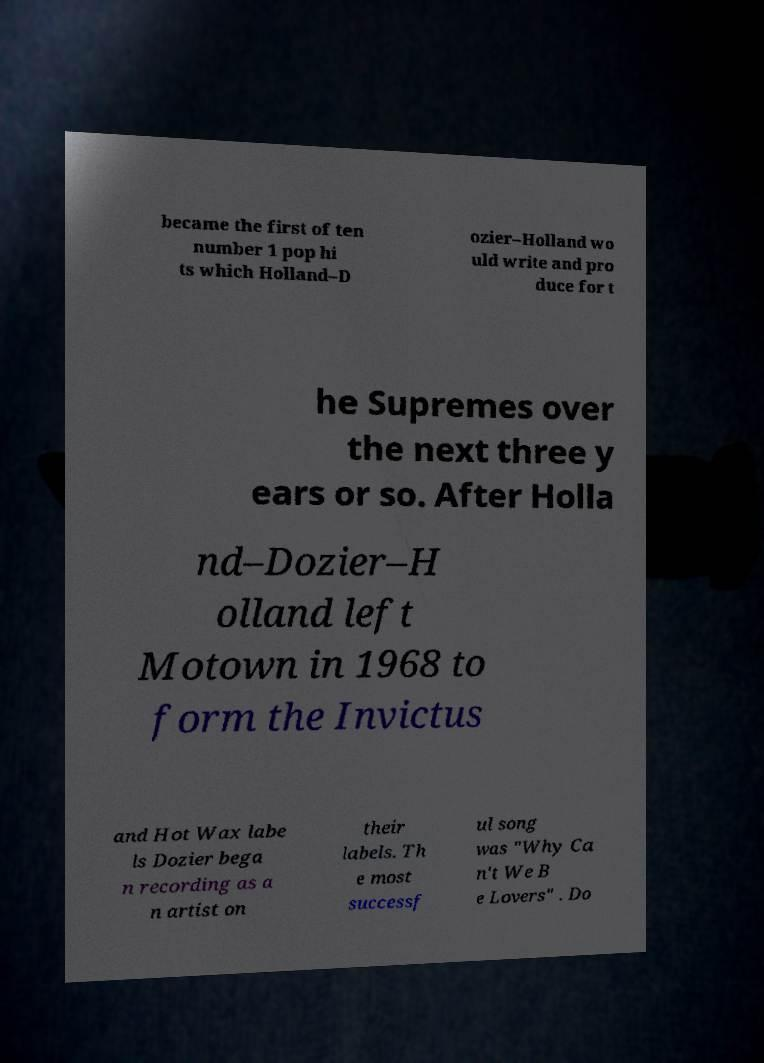Please read and relay the text visible in this image. What does it say? became the first of ten number 1 pop hi ts which Holland–D ozier–Holland wo uld write and pro duce for t he Supremes over the next three y ears or so. After Holla nd–Dozier–H olland left Motown in 1968 to form the Invictus and Hot Wax labe ls Dozier bega n recording as a n artist on their labels. Th e most successf ul song was "Why Ca n't We B e Lovers" . Do 